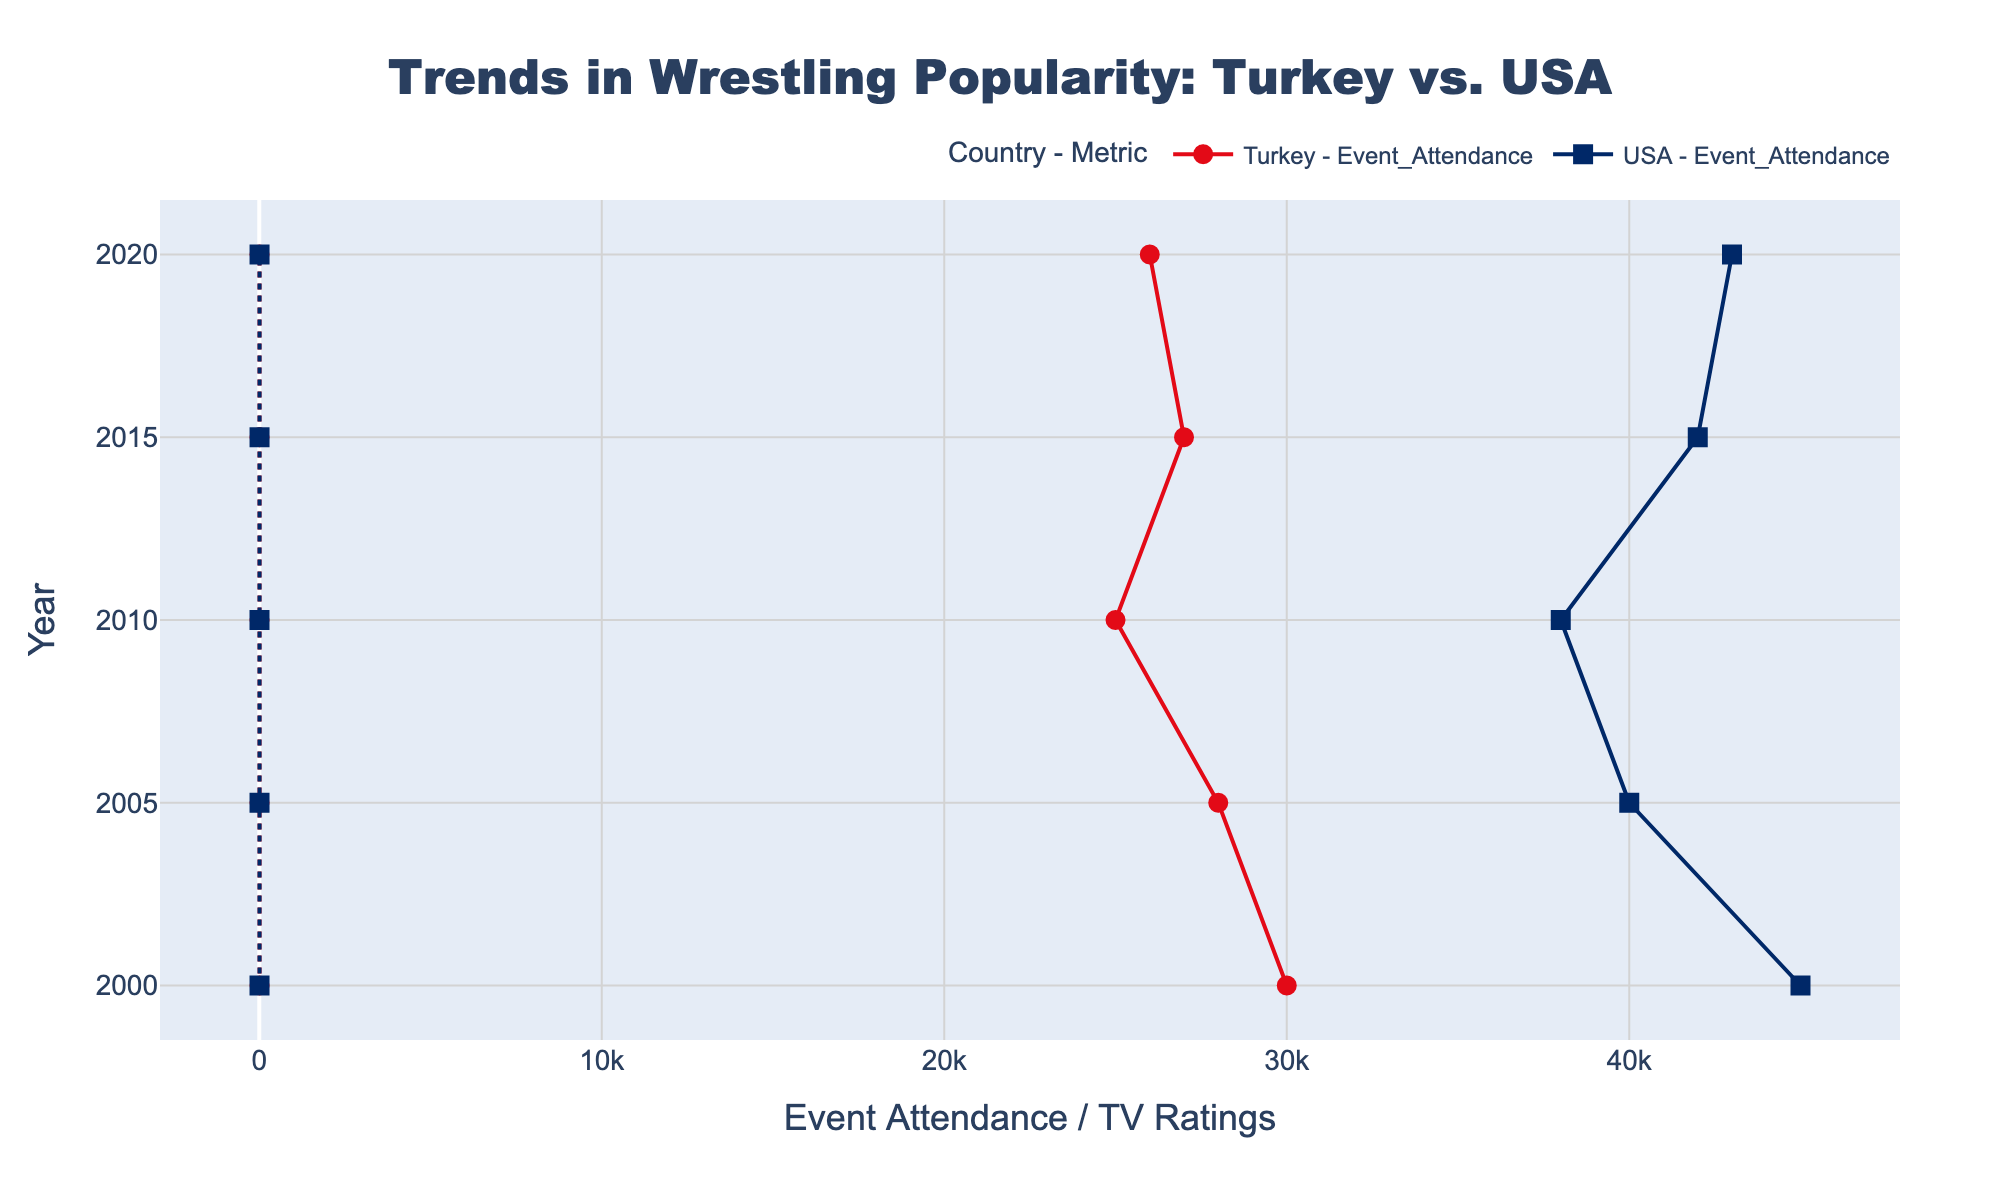What's the title of the plot? The title is displayed at the top of the plot and is used to describe what the plot represents. It states "Trends in Wrestling Popularity: Turkey vs. USA".
Answer: Trends in Wrestling Popularity: Turkey vs. USA What are the variables plotted on the x-axis and y-axis? The x-axis represents "Event Attendance / TV Ratings", and the y-axis represents the "Year". This can be inferred from the axis titles.
Answer: Event Attendance / TV Ratings and Year In which year did Turkey experience the highest TV Ratings? By observing the markers labeled for Turkey in the plot, the highest point on the TV Ratings axis is at 8.5 in the year 2000.
Answer: 2000 How many unique data points are included in the plot? Each year-country combination has two data points (Event Attendance and TV Ratings). There are 5 years and 2 countries, so the total number of unique data points is 5 * 2 * 2 = 20.
Answer: 20 Which country showed a greater increase in Event Attendance from 2010 to 2015? For Turkey, Event Attendance increased from 25,000 to 27,000 (an increase of 2,000). For the USA, Event Attendance increased from 38,000 to 42,000 (an increase of 4,000). Thus, the USA showed a greater increase.
Answer: USA In 2015, which country had higher TV Ratings and by how much? Looking at the TV Ratings for the year 2015, Turkey had a rating of 7.2 and the USA had a rating of 7.4. The USA had higher ratings by 0.2.
Answer: USA by 0.2 Compare the trend of Event Attendance in Turkey from 2000 to 2020. Did it increase or decrease overall? Examine the Event Attendance values for Turkey in 2000 (30,000), 2005 (28,000), 2010 (25,000), 2015 (27,000), and 2020 (26,000). There is an overall decreasing trend.
Answer: Decrease Which year marked the lowest Event Attendance for Turkey? The lowest point on the Event Attendance line for Turkey is at 25,000 in the year 2010.
Answer: 2010 Did TV Ratings for the USA increase or decrease overall from 2000 to 2020? Observing the TV Ratings for the USA in 2000 (7.2), 2005 (7.0), 2010 (6.5), 2015 (7.4), and 2020 (7.8), there is an overall increasing trend.
Answer: Increase 